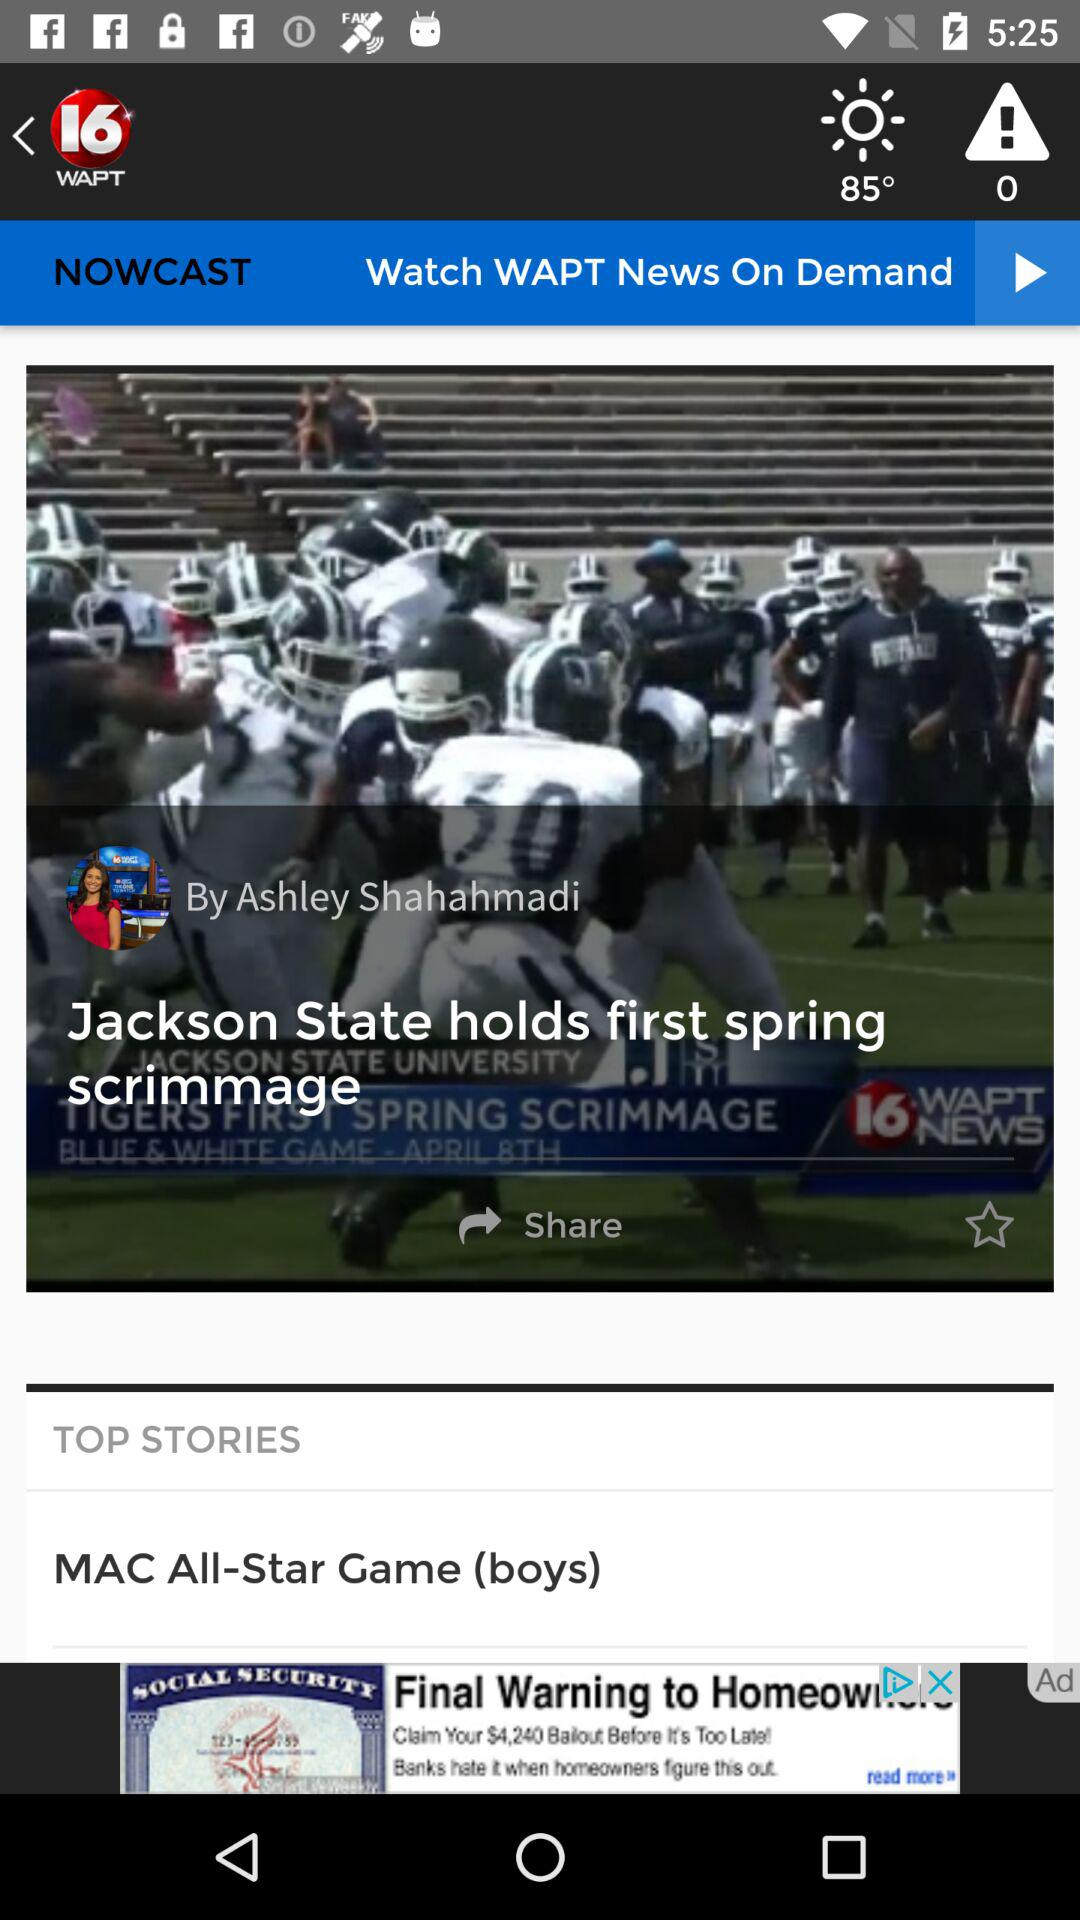What is the reporter name? The reporter name is Ashley Shahahmadi. 